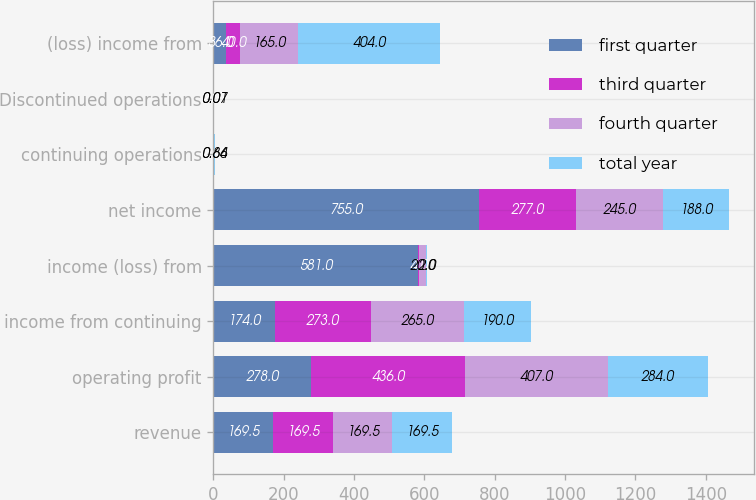Convert chart. <chart><loc_0><loc_0><loc_500><loc_500><stacked_bar_chart><ecel><fcel>revenue<fcel>operating profit<fcel>income from continuing<fcel>income (loss) from<fcel>net income<fcel>continuing operations<fcel>Discontinued operations<fcel>(loss) income from<nl><fcel>first quarter<fcel>169.5<fcel>278<fcel>174<fcel>581<fcel>755<fcel>0.55<fcel>2.07<fcel>36<nl><fcel>third quarter<fcel>169.5<fcel>436<fcel>273<fcel>4<fcel>277<fcel>0.91<fcel>0.01<fcel>40<nl><fcel>fourth quarter<fcel>169.5<fcel>407<fcel>265<fcel>20<fcel>245<fcel>0.86<fcel>0.07<fcel>165<nl><fcel>total year<fcel>169.5<fcel>284<fcel>190<fcel>2<fcel>188<fcel>0.64<fcel>0.01<fcel>404<nl></chart> 